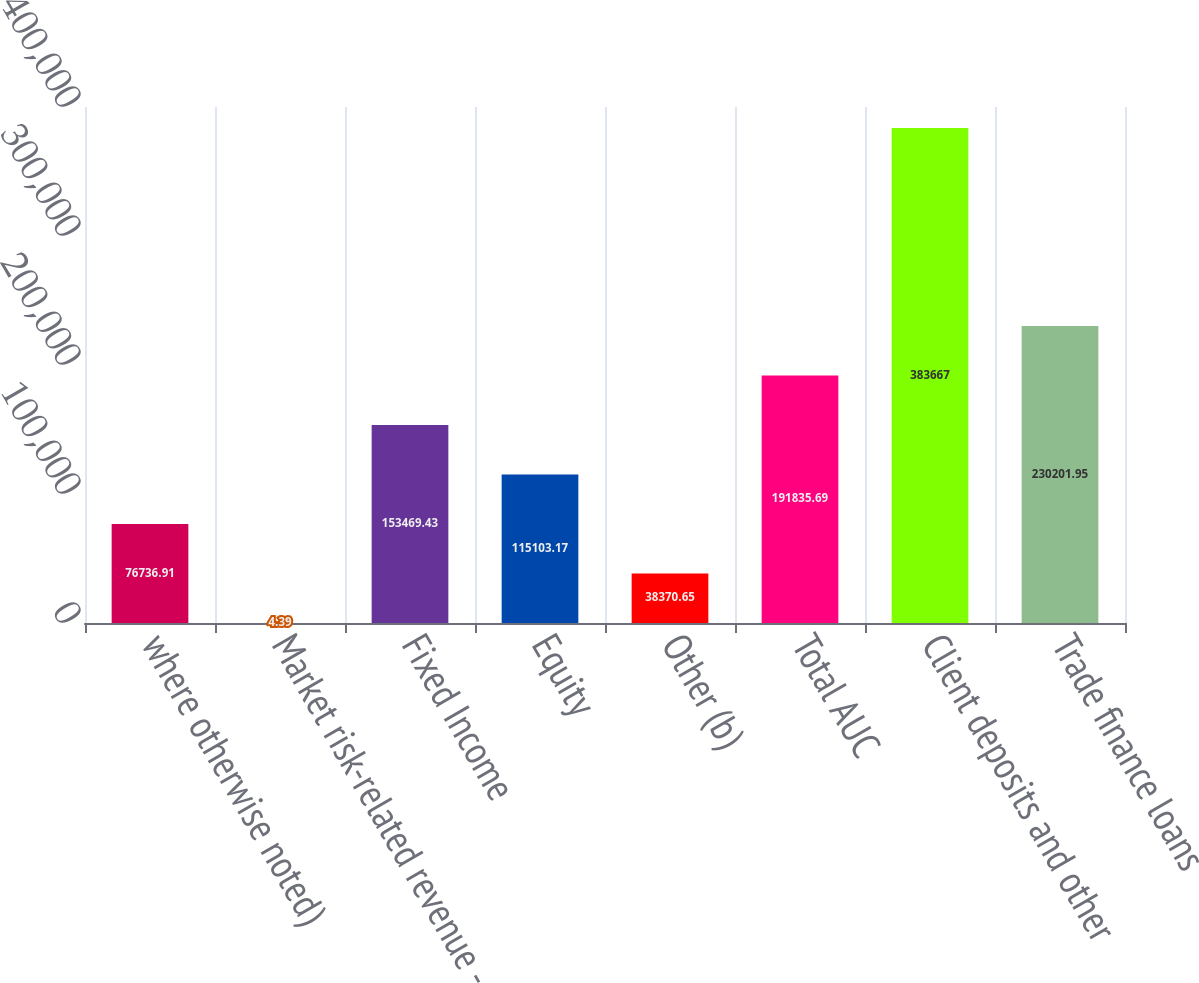Convert chart. <chart><loc_0><loc_0><loc_500><loc_500><bar_chart><fcel>where otherwise noted)<fcel>Market risk-related revenue -<fcel>Fixed Income<fcel>Equity<fcel>Other (b)<fcel>Total AUC<fcel>Client deposits and other<fcel>Trade finance loans<nl><fcel>76736.9<fcel>4.39<fcel>153469<fcel>115103<fcel>38370.7<fcel>191836<fcel>383667<fcel>230202<nl></chart> 